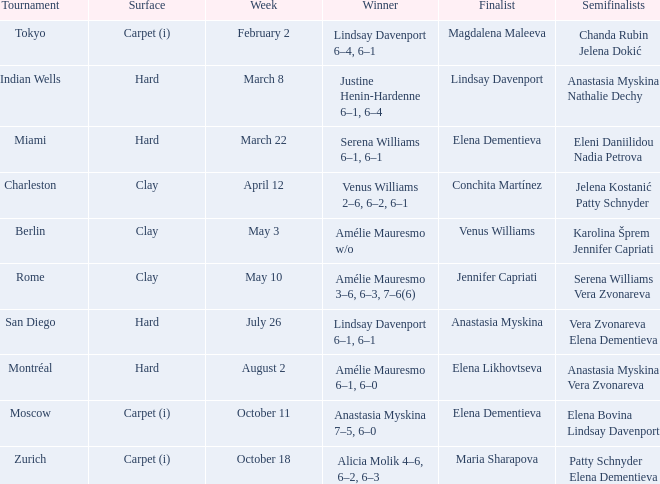Who claimed the championship in the miami event where elena dementieva was a finalist? Serena Williams 6–1, 6–1. 